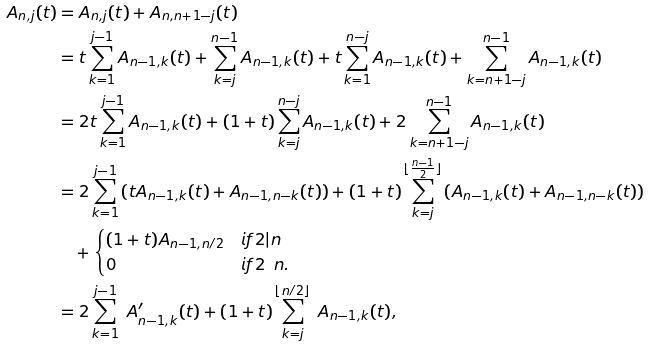Convert formula to latex. <formula><loc_0><loc_0><loc_500><loc_500>\ A _ { n , j } ( t ) & = A _ { n , j } ( t ) + A _ { n , n + 1 - j } ( t ) \\ & = t \sum _ { k = 1 } ^ { j - 1 } A _ { n - 1 , k } ( t ) + \sum _ { k = j } ^ { n - 1 } A _ { n - 1 , k } ( t ) + t \sum _ { k = 1 } ^ { n - j } A _ { n - 1 , k } ( t ) + \sum _ { k = n + 1 - j } ^ { n - 1 } A _ { n - 1 , k } ( t ) \\ & = 2 t \sum _ { k = 1 } ^ { j - 1 } A _ { n - 1 , k } ( t ) + ( 1 + t ) \sum _ { k = j } ^ { n - j } A _ { n - 1 , k } ( t ) + 2 \sum _ { k = n + 1 - j } ^ { n - 1 } A _ { n - 1 , k } ( t ) \\ & = 2 \sum _ { k = 1 } ^ { j - 1 } \left ( t A _ { n - 1 , k } ( t ) + A _ { n - 1 , n - k } ( t ) \right ) + ( 1 + t ) \sum _ { k = j } ^ { \lfloor \frac { n - 1 } { 2 } \rfloor } \left ( A _ { n - 1 , k } ( t ) + A _ { n - 1 , n - k } ( t ) \right ) \\ & \quad + \begin{cases} ( 1 + t ) A _ { n - 1 , n / 2 } & i f 2 | n \\ 0 & i f 2 \nmid n . \end{cases} \\ & = 2 \sum _ { k = 1 } ^ { j - 1 } \ A ^ { \prime } _ { n - 1 , k } ( t ) + ( 1 + t ) \sum _ { k = j } ^ { \lfloor n / 2 \rfloor } \ A _ { n - 1 , k } ( t ) ,</formula> 